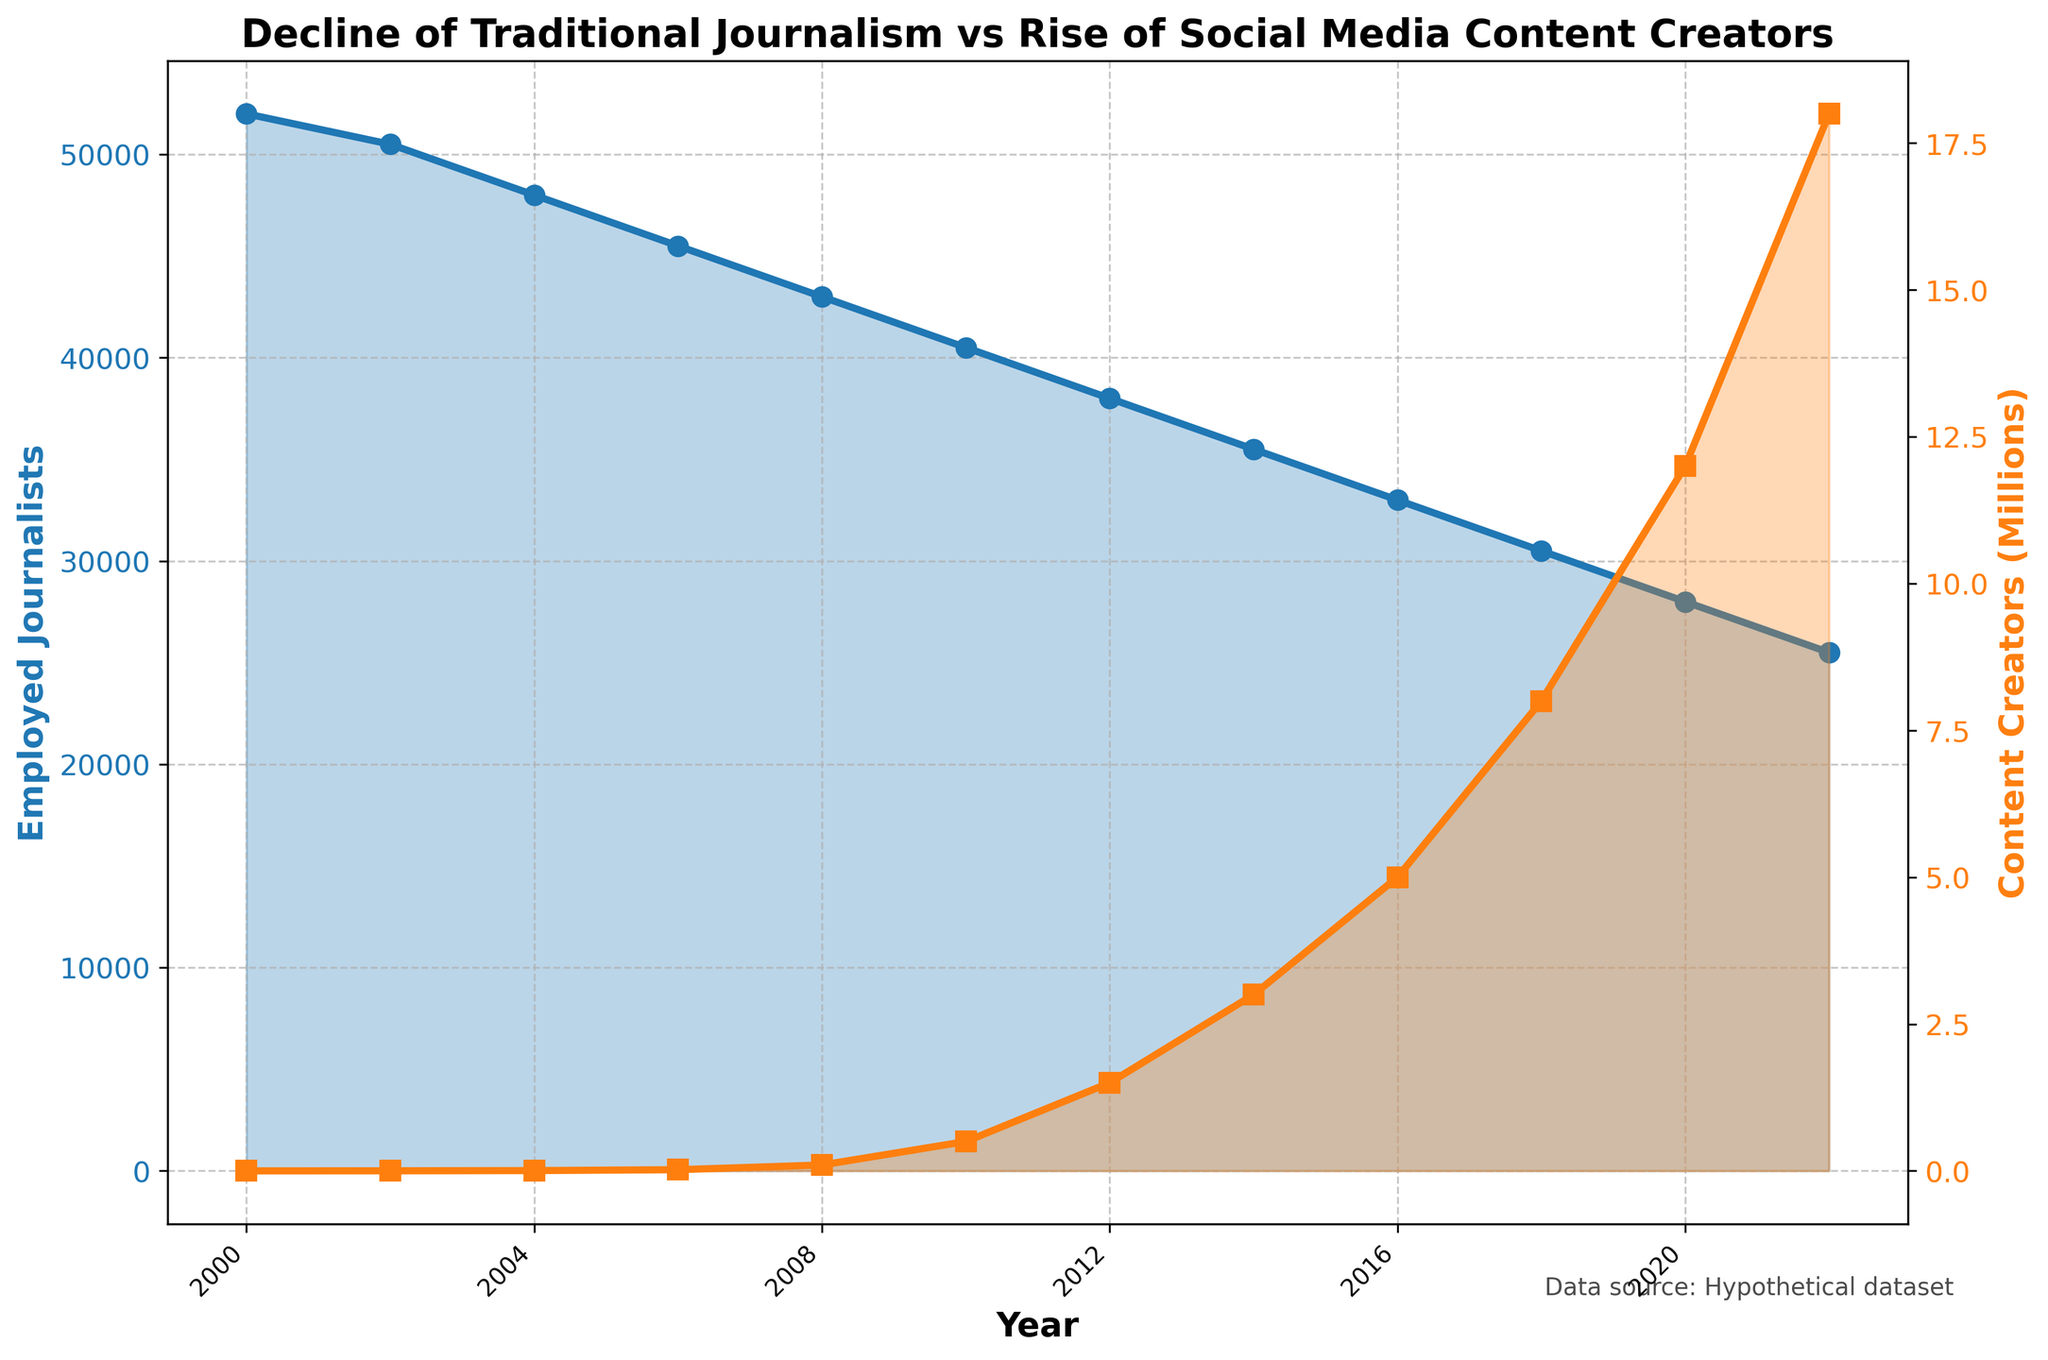What year did the number of employed journalists in traditional media fall below 40,000? By looking at the plot for employed journalists in traditional media, we can see that the value drops below 40,000 around 2012.
Answer: 2012 By how much did the number of content creators on social platforms increase between 2002 and 2006? In 2002, the number of content creators was 1,000, and by 2006 it increased to 20,000. Calculating the difference: 20,000 - 1,000 = 19,000.
Answer: 19,000 What was the approximate ratio of content creators to employed journalists in traditional media in 2020? In 2020, there were about 12,000,000 content creators and 28,000 employed journalists. The ratio is calculated as 12,000,000 / 28,000 = approximately 428.57.
Answer: 428.57 What trend can be observed in the number of employed journalists from 2000 to 2022? The plot shows a continuous decline in the number of employed journalists over the years. This trend indicates a significant reduction in traditional journalism employment.
Answer: Continuous decline Which year experienced the highest rise in the number of content creators compared to the previous year, based on the visual trend? The plot shows the most significant jump in content creators between 2008 and 2010, where the number rose from approximately 100,000 to 500,000, a 400,000 increase.
Answer: 2010 Compare the number of content creators on social platforms in 2008 and 2018. In 2008, there were 100,000 content creators, and by 2018, there were 8,000,000. The number of content creators increased significantly over these ten years.
Answer: 8,000,000 What is the overall trend for content creators on social platforms from 2000 to 2022? The line for content creators on social platforms shows a strong upward trend, indicating a rapid increase in the number of content creators over the years.
Answer: Strong upward trend Calculate the difference in the number of employed journalists from 2000 to 2022. In 2000, there were 52,000 employed journalists, and in 2022, there were 25,500. The difference is 52,000 - 25,500 = 26,500.
Answer: 26,500 In what year did the number of content creators reach one million? The number of content creators reached one million between 2008 (100,000) and 2010 (500,000), most closely approximated around 2010 given the visual trend.
Answer: 2010 Which line color represents the content creators on social platforms? The color representing content creators on social platforms is orange.
Answer: Orange 